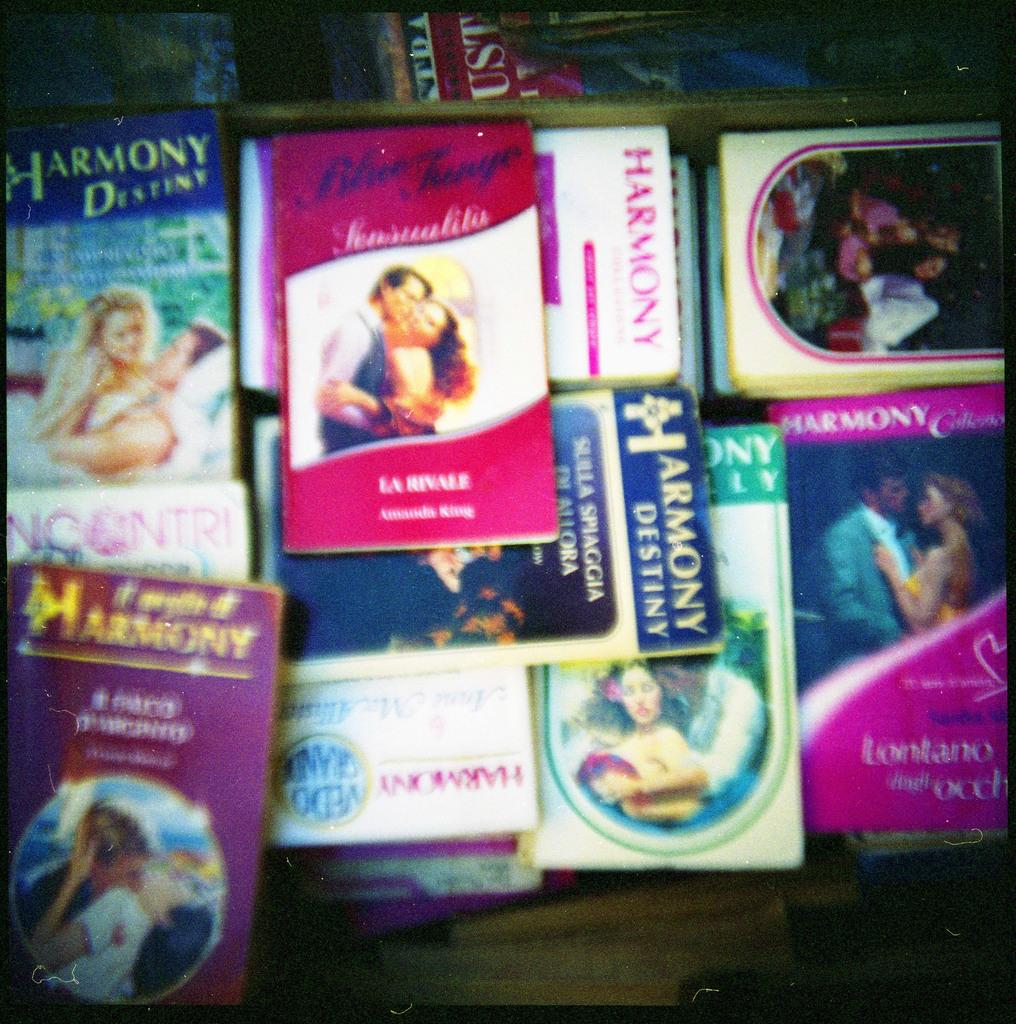What is the main feature of the image? The main feature of the image is a surface. What can be seen on the surface? There are many books placed on the surface. What is the limit of the books on the surface in the image? There is no mention of a limit for the books on the surface in the image. 